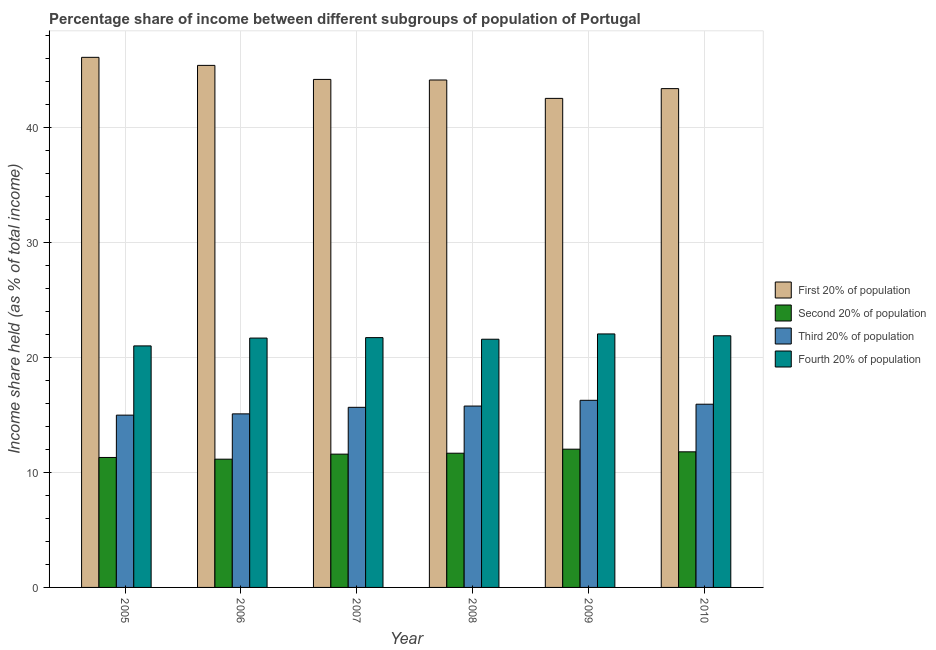How many different coloured bars are there?
Ensure brevity in your answer.  4. Are the number of bars per tick equal to the number of legend labels?
Make the answer very short. Yes. How many bars are there on the 2nd tick from the left?
Provide a succinct answer. 4. What is the label of the 5th group of bars from the left?
Your answer should be compact. 2009. What is the share of the income held by first 20% of the population in 2010?
Provide a succinct answer. 43.37. Across all years, what is the maximum share of the income held by second 20% of the population?
Make the answer very short. 12.02. Across all years, what is the minimum share of the income held by first 20% of the population?
Offer a very short reply. 42.52. In which year was the share of the income held by second 20% of the population maximum?
Offer a terse response. 2009. In which year was the share of the income held by third 20% of the population minimum?
Keep it short and to the point. 2005. What is the total share of the income held by first 20% of the population in the graph?
Provide a succinct answer. 265.66. What is the difference between the share of the income held by third 20% of the population in 2006 and that in 2008?
Offer a very short reply. -0.68. What is the difference between the share of the income held by second 20% of the population in 2007 and the share of the income held by fourth 20% of the population in 2006?
Offer a terse response. 0.44. What is the average share of the income held by third 20% of the population per year?
Offer a terse response. 15.62. In how many years, is the share of the income held by third 20% of the population greater than 2 %?
Ensure brevity in your answer.  6. What is the ratio of the share of the income held by first 20% of the population in 2005 to that in 2007?
Your answer should be compact. 1.04. Is the share of the income held by fourth 20% of the population in 2008 less than that in 2009?
Give a very brief answer. Yes. Is the difference between the share of the income held by third 20% of the population in 2005 and 2007 greater than the difference between the share of the income held by first 20% of the population in 2005 and 2007?
Make the answer very short. No. What is the difference between the highest and the second highest share of the income held by third 20% of the population?
Your response must be concise. 0.34. What is the difference between the highest and the lowest share of the income held by fourth 20% of the population?
Keep it short and to the point. 1.04. Is the sum of the share of the income held by first 20% of the population in 2008 and 2009 greater than the maximum share of the income held by fourth 20% of the population across all years?
Keep it short and to the point. Yes. Is it the case that in every year, the sum of the share of the income held by third 20% of the population and share of the income held by fourth 20% of the population is greater than the sum of share of the income held by second 20% of the population and share of the income held by first 20% of the population?
Provide a succinct answer. No. What does the 4th bar from the left in 2005 represents?
Offer a terse response. Fourth 20% of population. What does the 4th bar from the right in 2006 represents?
Your answer should be compact. First 20% of population. How many years are there in the graph?
Your response must be concise. 6. Does the graph contain grids?
Ensure brevity in your answer.  Yes. How many legend labels are there?
Offer a very short reply. 4. How are the legend labels stacked?
Keep it short and to the point. Vertical. What is the title of the graph?
Give a very brief answer. Percentage share of income between different subgroups of population of Portugal. What is the label or title of the Y-axis?
Give a very brief answer. Income share held (as % of total income). What is the Income share held (as % of total income) of First 20% of population in 2005?
Your response must be concise. 46.09. What is the Income share held (as % of total income) of Second 20% of population in 2005?
Your response must be concise. 11.3. What is the Income share held (as % of total income) in Third 20% of population in 2005?
Provide a succinct answer. 14.98. What is the Income share held (as % of total income) in First 20% of population in 2006?
Ensure brevity in your answer.  45.39. What is the Income share held (as % of total income) of Second 20% of population in 2006?
Give a very brief answer. 11.15. What is the Income share held (as % of total income) in Third 20% of population in 2006?
Offer a very short reply. 15.09. What is the Income share held (as % of total income) in Fourth 20% of population in 2006?
Keep it short and to the point. 21.68. What is the Income share held (as % of total income) in First 20% of population in 2007?
Provide a short and direct response. 44.17. What is the Income share held (as % of total income) in Second 20% of population in 2007?
Provide a succinct answer. 11.59. What is the Income share held (as % of total income) of Third 20% of population in 2007?
Provide a short and direct response. 15.66. What is the Income share held (as % of total income) of Fourth 20% of population in 2007?
Your answer should be very brief. 21.72. What is the Income share held (as % of total income) of First 20% of population in 2008?
Make the answer very short. 44.12. What is the Income share held (as % of total income) in Second 20% of population in 2008?
Your response must be concise. 11.67. What is the Income share held (as % of total income) in Third 20% of population in 2008?
Your response must be concise. 15.77. What is the Income share held (as % of total income) in Fourth 20% of population in 2008?
Ensure brevity in your answer.  21.58. What is the Income share held (as % of total income) of First 20% of population in 2009?
Your response must be concise. 42.52. What is the Income share held (as % of total income) of Second 20% of population in 2009?
Provide a succinct answer. 12.02. What is the Income share held (as % of total income) of Third 20% of population in 2009?
Offer a terse response. 16.27. What is the Income share held (as % of total income) of Fourth 20% of population in 2009?
Your answer should be very brief. 22.04. What is the Income share held (as % of total income) in First 20% of population in 2010?
Offer a very short reply. 43.37. What is the Income share held (as % of total income) of Second 20% of population in 2010?
Your answer should be very brief. 11.79. What is the Income share held (as % of total income) of Third 20% of population in 2010?
Offer a terse response. 15.93. What is the Income share held (as % of total income) of Fourth 20% of population in 2010?
Provide a short and direct response. 21.88. Across all years, what is the maximum Income share held (as % of total income) of First 20% of population?
Provide a succinct answer. 46.09. Across all years, what is the maximum Income share held (as % of total income) in Second 20% of population?
Give a very brief answer. 12.02. Across all years, what is the maximum Income share held (as % of total income) in Third 20% of population?
Your answer should be very brief. 16.27. Across all years, what is the maximum Income share held (as % of total income) in Fourth 20% of population?
Your response must be concise. 22.04. Across all years, what is the minimum Income share held (as % of total income) of First 20% of population?
Keep it short and to the point. 42.52. Across all years, what is the minimum Income share held (as % of total income) in Second 20% of population?
Provide a succinct answer. 11.15. Across all years, what is the minimum Income share held (as % of total income) in Third 20% of population?
Ensure brevity in your answer.  14.98. What is the total Income share held (as % of total income) in First 20% of population in the graph?
Offer a terse response. 265.66. What is the total Income share held (as % of total income) of Second 20% of population in the graph?
Ensure brevity in your answer.  69.52. What is the total Income share held (as % of total income) in Third 20% of population in the graph?
Your answer should be compact. 93.7. What is the total Income share held (as % of total income) in Fourth 20% of population in the graph?
Provide a succinct answer. 129.9. What is the difference between the Income share held (as % of total income) in Third 20% of population in 2005 and that in 2006?
Your response must be concise. -0.11. What is the difference between the Income share held (as % of total income) of Fourth 20% of population in 2005 and that in 2006?
Provide a succinct answer. -0.68. What is the difference between the Income share held (as % of total income) in First 20% of population in 2005 and that in 2007?
Offer a very short reply. 1.92. What is the difference between the Income share held (as % of total income) of Second 20% of population in 2005 and that in 2007?
Make the answer very short. -0.29. What is the difference between the Income share held (as % of total income) of Third 20% of population in 2005 and that in 2007?
Your response must be concise. -0.68. What is the difference between the Income share held (as % of total income) of Fourth 20% of population in 2005 and that in 2007?
Offer a terse response. -0.72. What is the difference between the Income share held (as % of total income) of First 20% of population in 2005 and that in 2008?
Your response must be concise. 1.97. What is the difference between the Income share held (as % of total income) of Second 20% of population in 2005 and that in 2008?
Offer a very short reply. -0.37. What is the difference between the Income share held (as % of total income) of Third 20% of population in 2005 and that in 2008?
Provide a short and direct response. -0.79. What is the difference between the Income share held (as % of total income) in Fourth 20% of population in 2005 and that in 2008?
Your answer should be compact. -0.58. What is the difference between the Income share held (as % of total income) of First 20% of population in 2005 and that in 2009?
Your answer should be compact. 3.57. What is the difference between the Income share held (as % of total income) of Second 20% of population in 2005 and that in 2009?
Your answer should be very brief. -0.72. What is the difference between the Income share held (as % of total income) of Third 20% of population in 2005 and that in 2009?
Your response must be concise. -1.29. What is the difference between the Income share held (as % of total income) in Fourth 20% of population in 2005 and that in 2009?
Provide a short and direct response. -1.04. What is the difference between the Income share held (as % of total income) of First 20% of population in 2005 and that in 2010?
Your answer should be compact. 2.72. What is the difference between the Income share held (as % of total income) of Second 20% of population in 2005 and that in 2010?
Offer a very short reply. -0.49. What is the difference between the Income share held (as % of total income) in Third 20% of population in 2005 and that in 2010?
Provide a short and direct response. -0.95. What is the difference between the Income share held (as % of total income) of Fourth 20% of population in 2005 and that in 2010?
Provide a short and direct response. -0.88. What is the difference between the Income share held (as % of total income) of First 20% of population in 2006 and that in 2007?
Provide a short and direct response. 1.22. What is the difference between the Income share held (as % of total income) of Second 20% of population in 2006 and that in 2007?
Your answer should be compact. -0.44. What is the difference between the Income share held (as % of total income) of Third 20% of population in 2006 and that in 2007?
Offer a very short reply. -0.57. What is the difference between the Income share held (as % of total income) in Fourth 20% of population in 2006 and that in 2007?
Make the answer very short. -0.04. What is the difference between the Income share held (as % of total income) of First 20% of population in 2006 and that in 2008?
Offer a very short reply. 1.27. What is the difference between the Income share held (as % of total income) in Second 20% of population in 2006 and that in 2008?
Offer a very short reply. -0.52. What is the difference between the Income share held (as % of total income) in Third 20% of population in 2006 and that in 2008?
Your answer should be very brief. -0.68. What is the difference between the Income share held (as % of total income) of Fourth 20% of population in 2006 and that in 2008?
Make the answer very short. 0.1. What is the difference between the Income share held (as % of total income) of First 20% of population in 2006 and that in 2009?
Offer a terse response. 2.87. What is the difference between the Income share held (as % of total income) in Second 20% of population in 2006 and that in 2009?
Give a very brief answer. -0.87. What is the difference between the Income share held (as % of total income) in Third 20% of population in 2006 and that in 2009?
Your response must be concise. -1.18. What is the difference between the Income share held (as % of total income) in Fourth 20% of population in 2006 and that in 2009?
Your response must be concise. -0.36. What is the difference between the Income share held (as % of total income) of First 20% of population in 2006 and that in 2010?
Offer a terse response. 2.02. What is the difference between the Income share held (as % of total income) in Second 20% of population in 2006 and that in 2010?
Give a very brief answer. -0.64. What is the difference between the Income share held (as % of total income) of Third 20% of population in 2006 and that in 2010?
Offer a terse response. -0.84. What is the difference between the Income share held (as % of total income) of Fourth 20% of population in 2006 and that in 2010?
Offer a very short reply. -0.2. What is the difference between the Income share held (as % of total income) of Second 20% of population in 2007 and that in 2008?
Make the answer very short. -0.08. What is the difference between the Income share held (as % of total income) in Third 20% of population in 2007 and that in 2008?
Ensure brevity in your answer.  -0.11. What is the difference between the Income share held (as % of total income) in Fourth 20% of population in 2007 and that in 2008?
Offer a terse response. 0.14. What is the difference between the Income share held (as % of total income) of First 20% of population in 2007 and that in 2009?
Provide a short and direct response. 1.65. What is the difference between the Income share held (as % of total income) of Second 20% of population in 2007 and that in 2009?
Your answer should be compact. -0.43. What is the difference between the Income share held (as % of total income) in Third 20% of population in 2007 and that in 2009?
Your answer should be very brief. -0.61. What is the difference between the Income share held (as % of total income) of Fourth 20% of population in 2007 and that in 2009?
Your answer should be compact. -0.32. What is the difference between the Income share held (as % of total income) in Third 20% of population in 2007 and that in 2010?
Offer a terse response. -0.27. What is the difference between the Income share held (as % of total income) in Fourth 20% of population in 2007 and that in 2010?
Your response must be concise. -0.16. What is the difference between the Income share held (as % of total income) in Second 20% of population in 2008 and that in 2009?
Offer a terse response. -0.35. What is the difference between the Income share held (as % of total income) of Fourth 20% of population in 2008 and that in 2009?
Keep it short and to the point. -0.46. What is the difference between the Income share held (as % of total income) in First 20% of population in 2008 and that in 2010?
Offer a terse response. 0.75. What is the difference between the Income share held (as % of total income) in Second 20% of population in 2008 and that in 2010?
Give a very brief answer. -0.12. What is the difference between the Income share held (as % of total income) in Third 20% of population in 2008 and that in 2010?
Make the answer very short. -0.16. What is the difference between the Income share held (as % of total income) of First 20% of population in 2009 and that in 2010?
Provide a succinct answer. -0.85. What is the difference between the Income share held (as % of total income) of Second 20% of population in 2009 and that in 2010?
Your answer should be compact. 0.23. What is the difference between the Income share held (as % of total income) in Third 20% of population in 2009 and that in 2010?
Your answer should be very brief. 0.34. What is the difference between the Income share held (as % of total income) of Fourth 20% of population in 2009 and that in 2010?
Ensure brevity in your answer.  0.16. What is the difference between the Income share held (as % of total income) of First 20% of population in 2005 and the Income share held (as % of total income) of Second 20% of population in 2006?
Provide a succinct answer. 34.94. What is the difference between the Income share held (as % of total income) in First 20% of population in 2005 and the Income share held (as % of total income) in Fourth 20% of population in 2006?
Offer a terse response. 24.41. What is the difference between the Income share held (as % of total income) in Second 20% of population in 2005 and the Income share held (as % of total income) in Third 20% of population in 2006?
Offer a terse response. -3.79. What is the difference between the Income share held (as % of total income) in Second 20% of population in 2005 and the Income share held (as % of total income) in Fourth 20% of population in 2006?
Ensure brevity in your answer.  -10.38. What is the difference between the Income share held (as % of total income) in First 20% of population in 2005 and the Income share held (as % of total income) in Second 20% of population in 2007?
Offer a very short reply. 34.5. What is the difference between the Income share held (as % of total income) of First 20% of population in 2005 and the Income share held (as % of total income) of Third 20% of population in 2007?
Provide a succinct answer. 30.43. What is the difference between the Income share held (as % of total income) in First 20% of population in 2005 and the Income share held (as % of total income) in Fourth 20% of population in 2007?
Your answer should be compact. 24.37. What is the difference between the Income share held (as % of total income) of Second 20% of population in 2005 and the Income share held (as % of total income) of Third 20% of population in 2007?
Your response must be concise. -4.36. What is the difference between the Income share held (as % of total income) of Second 20% of population in 2005 and the Income share held (as % of total income) of Fourth 20% of population in 2007?
Provide a succinct answer. -10.42. What is the difference between the Income share held (as % of total income) in Third 20% of population in 2005 and the Income share held (as % of total income) in Fourth 20% of population in 2007?
Your response must be concise. -6.74. What is the difference between the Income share held (as % of total income) of First 20% of population in 2005 and the Income share held (as % of total income) of Second 20% of population in 2008?
Your answer should be compact. 34.42. What is the difference between the Income share held (as % of total income) of First 20% of population in 2005 and the Income share held (as % of total income) of Third 20% of population in 2008?
Make the answer very short. 30.32. What is the difference between the Income share held (as % of total income) in First 20% of population in 2005 and the Income share held (as % of total income) in Fourth 20% of population in 2008?
Keep it short and to the point. 24.51. What is the difference between the Income share held (as % of total income) in Second 20% of population in 2005 and the Income share held (as % of total income) in Third 20% of population in 2008?
Your response must be concise. -4.47. What is the difference between the Income share held (as % of total income) of Second 20% of population in 2005 and the Income share held (as % of total income) of Fourth 20% of population in 2008?
Your answer should be compact. -10.28. What is the difference between the Income share held (as % of total income) of Third 20% of population in 2005 and the Income share held (as % of total income) of Fourth 20% of population in 2008?
Provide a succinct answer. -6.6. What is the difference between the Income share held (as % of total income) in First 20% of population in 2005 and the Income share held (as % of total income) in Second 20% of population in 2009?
Ensure brevity in your answer.  34.07. What is the difference between the Income share held (as % of total income) of First 20% of population in 2005 and the Income share held (as % of total income) of Third 20% of population in 2009?
Your answer should be very brief. 29.82. What is the difference between the Income share held (as % of total income) in First 20% of population in 2005 and the Income share held (as % of total income) in Fourth 20% of population in 2009?
Your answer should be very brief. 24.05. What is the difference between the Income share held (as % of total income) of Second 20% of population in 2005 and the Income share held (as % of total income) of Third 20% of population in 2009?
Your response must be concise. -4.97. What is the difference between the Income share held (as % of total income) in Second 20% of population in 2005 and the Income share held (as % of total income) in Fourth 20% of population in 2009?
Make the answer very short. -10.74. What is the difference between the Income share held (as % of total income) of Third 20% of population in 2005 and the Income share held (as % of total income) of Fourth 20% of population in 2009?
Provide a succinct answer. -7.06. What is the difference between the Income share held (as % of total income) of First 20% of population in 2005 and the Income share held (as % of total income) of Second 20% of population in 2010?
Provide a short and direct response. 34.3. What is the difference between the Income share held (as % of total income) of First 20% of population in 2005 and the Income share held (as % of total income) of Third 20% of population in 2010?
Keep it short and to the point. 30.16. What is the difference between the Income share held (as % of total income) in First 20% of population in 2005 and the Income share held (as % of total income) in Fourth 20% of population in 2010?
Your answer should be compact. 24.21. What is the difference between the Income share held (as % of total income) in Second 20% of population in 2005 and the Income share held (as % of total income) in Third 20% of population in 2010?
Your answer should be compact. -4.63. What is the difference between the Income share held (as % of total income) of Second 20% of population in 2005 and the Income share held (as % of total income) of Fourth 20% of population in 2010?
Keep it short and to the point. -10.58. What is the difference between the Income share held (as % of total income) in First 20% of population in 2006 and the Income share held (as % of total income) in Second 20% of population in 2007?
Your response must be concise. 33.8. What is the difference between the Income share held (as % of total income) of First 20% of population in 2006 and the Income share held (as % of total income) of Third 20% of population in 2007?
Make the answer very short. 29.73. What is the difference between the Income share held (as % of total income) of First 20% of population in 2006 and the Income share held (as % of total income) of Fourth 20% of population in 2007?
Provide a short and direct response. 23.67. What is the difference between the Income share held (as % of total income) of Second 20% of population in 2006 and the Income share held (as % of total income) of Third 20% of population in 2007?
Offer a very short reply. -4.51. What is the difference between the Income share held (as % of total income) in Second 20% of population in 2006 and the Income share held (as % of total income) in Fourth 20% of population in 2007?
Ensure brevity in your answer.  -10.57. What is the difference between the Income share held (as % of total income) of Third 20% of population in 2006 and the Income share held (as % of total income) of Fourth 20% of population in 2007?
Give a very brief answer. -6.63. What is the difference between the Income share held (as % of total income) of First 20% of population in 2006 and the Income share held (as % of total income) of Second 20% of population in 2008?
Offer a terse response. 33.72. What is the difference between the Income share held (as % of total income) of First 20% of population in 2006 and the Income share held (as % of total income) of Third 20% of population in 2008?
Make the answer very short. 29.62. What is the difference between the Income share held (as % of total income) in First 20% of population in 2006 and the Income share held (as % of total income) in Fourth 20% of population in 2008?
Provide a short and direct response. 23.81. What is the difference between the Income share held (as % of total income) in Second 20% of population in 2006 and the Income share held (as % of total income) in Third 20% of population in 2008?
Offer a terse response. -4.62. What is the difference between the Income share held (as % of total income) in Second 20% of population in 2006 and the Income share held (as % of total income) in Fourth 20% of population in 2008?
Provide a succinct answer. -10.43. What is the difference between the Income share held (as % of total income) of Third 20% of population in 2006 and the Income share held (as % of total income) of Fourth 20% of population in 2008?
Keep it short and to the point. -6.49. What is the difference between the Income share held (as % of total income) of First 20% of population in 2006 and the Income share held (as % of total income) of Second 20% of population in 2009?
Offer a terse response. 33.37. What is the difference between the Income share held (as % of total income) of First 20% of population in 2006 and the Income share held (as % of total income) of Third 20% of population in 2009?
Ensure brevity in your answer.  29.12. What is the difference between the Income share held (as % of total income) in First 20% of population in 2006 and the Income share held (as % of total income) in Fourth 20% of population in 2009?
Ensure brevity in your answer.  23.35. What is the difference between the Income share held (as % of total income) in Second 20% of population in 2006 and the Income share held (as % of total income) in Third 20% of population in 2009?
Offer a very short reply. -5.12. What is the difference between the Income share held (as % of total income) of Second 20% of population in 2006 and the Income share held (as % of total income) of Fourth 20% of population in 2009?
Give a very brief answer. -10.89. What is the difference between the Income share held (as % of total income) in Third 20% of population in 2006 and the Income share held (as % of total income) in Fourth 20% of population in 2009?
Ensure brevity in your answer.  -6.95. What is the difference between the Income share held (as % of total income) of First 20% of population in 2006 and the Income share held (as % of total income) of Second 20% of population in 2010?
Keep it short and to the point. 33.6. What is the difference between the Income share held (as % of total income) of First 20% of population in 2006 and the Income share held (as % of total income) of Third 20% of population in 2010?
Your response must be concise. 29.46. What is the difference between the Income share held (as % of total income) in First 20% of population in 2006 and the Income share held (as % of total income) in Fourth 20% of population in 2010?
Offer a terse response. 23.51. What is the difference between the Income share held (as % of total income) in Second 20% of population in 2006 and the Income share held (as % of total income) in Third 20% of population in 2010?
Your answer should be compact. -4.78. What is the difference between the Income share held (as % of total income) in Second 20% of population in 2006 and the Income share held (as % of total income) in Fourth 20% of population in 2010?
Your answer should be compact. -10.73. What is the difference between the Income share held (as % of total income) of Third 20% of population in 2006 and the Income share held (as % of total income) of Fourth 20% of population in 2010?
Provide a short and direct response. -6.79. What is the difference between the Income share held (as % of total income) in First 20% of population in 2007 and the Income share held (as % of total income) in Second 20% of population in 2008?
Make the answer very short. 32.5. What is the difference between the Income share held (as % of total income) in First 20% of population in 2007 and the Income share held (as % of total income) in Third 20% of population in 2008?
Your response must be concise. 28.4. What is the difference between the Income share held (as % of total income) of First 20% of population in 2007 and the Income share held (as % of total income) of Fourth 20% of population in 2008?
Keep it short and to the point. 22.59. What is the difference between the Income share held (as % of total income) in Second 20% of population in 2007 and the Income share held (as % of total income) in Third 20% of population in 2008?
Your response must be concise. -4.18. What is the difference between the Income share held (as % of total income) of Second 20% of population in 2007 and the Income share held (as % of total income) of Fourth 20% of population in 2008?
Keep it short and to the point. -9.99. What is the difference between the Income share held (as % of total income) in Third 20% of population in 2007 and the Income share held (as % of total income) in Fourth 20% of population in 2008?
Give a very brief answer. -5.92. What is the difference between the Income share held (as % of total income) in First 20% of population in 2007 and the Income share held (as % of total income) in Second 20% of population in 2009?
Make the answer very short. 32.15. What is the difference between the Income share held (as % of total income) of First 20% of population in 2007 and the Income share held (as % of total income) of Third 20% of population in 2009?
Give a very brief answer. 27.9. What is the difference between the Income share held (as % of total income) of First 20% of population in 2007 and the Income share held (as % of total income) of Fourth 20% of population in 2009?
Your answer should be very brief. 22.13. What is the difference between the Income share held (as % of total income) in Second 20% of population in 2007 and the Income share held (as % of total income) in Third 20% of population in 2009?
Your response must be concise. -4.68. What is the difference between the Income share held (as % of total income) in Second 20% of population in 2007 and the Income share held (as % of total income) in Fourth 20% of population in 2009?
Your response must be concise. -10.45. What is the difference between the Income share held (as % of total income) of Third 20% of population in 2007 and the Income share held (as % of total income) of Fourth 20% of population in 2009?
Provide a succinct answer. -6.38. What is the difference between the Income share held (as % of total income) in First 20% of population in 2007 and the Income share held (as % of total income) in Second 20% of population in 2010?
Your answer should be compact. 32.38. What is the difference between the Income share held (as % of total income) in First 20% of population in 2007 and the Income share held (as % of total income) in Third 20% of population in 2010?
Offer a terse response. 28.24. What is the difference between the Income share held (as % of total income) of First 20% of population in 2007 and the Income share held (as % of total income) of Fourth 20% of population in 2010?
Your response must be concise. 22.29. What is the difference between the Income share held (as % of total income) in Second 20% of population in 2007 and the Income share held (as % of total income) in Third 20% of population in 2010?
Offer a very short reply. -4.34. What is the difference between the Income share held (as % of total income) of Second 20% of population in 2007 and the Income share held (as % of total income) of Fourth 20% of population in 2010?
Your answer should be compact. -10.29. What is the difference between the Income share held (as % of total income) of Third 20% of population in 2007 and the Income share held (as % of total income) of Fourth 20% of population in 2010?
Offer a terse response. -6.22. What is the difference between the Income share held (as % of total income) of First 20% of population in 2008 and the Income share held (as % of total income) of Second 20% of population in 2009?
Provide a short and direct response. 32.1. What is the difference between the Income share held (as % of total income) of First 20% of population in 2008 and the Income share held (as % of total income) of Third 20% of population in 2009?
Offer a very short reply. 27.85. What is the difference between the Income share held (as % of total income) of First 20% of population in 2008 and the Income share held (as % of total income) of Fourth 20% of population in 2009?
Give a very brief answer. 22.08. What is the difference between the Income share held (as % of total income) in Second 20% of population in 2008 and the Income share held (as % of total income) in Fourth 20% of population in 2009?
Provide a succinct answer. -10.37. What is the difference between the Income share held (as % of total income) of Third 20% of population in 2008 and the Income share held (as % of total income) of Fourth 20% of population in 2009?
Provide a short and direct response. -6.27. What is the difference between the Income share held (as % of total income) in First 20% of population in 2008 and the Income share held (as % of total income) in Second 20% of population in 2010?
Offer a terse response. 32.33. What is the difference between the Income share held (as % of total income) of First 20% of population in 2008 and the Income share held (as % of total income) of Third 20% of population in 2010?
Ensure brevity in your answer.  28.19. What is the difference between the Income share held (as % of total income) in First 20% of population in 2008 and the Income share held (as % of total income) in Fourth 20% of population in 2010?
Your response must be concise. 22.24. What is the difference between the Income share held (as % of total income) in Second 20% of population in 2008 and the Income share held (as % of total income) in Third 20% of population in 2010?
Your answer should be compact. -4.26. What is the difference between the Income share held (as % of total income) in Second 20% of population in 2008 and the Income share held (as % of total income) in Fourth 20% of population in 2010?
Provide a succinct answer. -10.21. What is the difference between the Income share held (as % of total income) of Third 20% of population in 2008 and the Income share held (as % of total income) of Fourth 20% of population in 2010?
Ensure brevity in your answer.  -6.11. What is the difference between the Income share held (as % of total income) of First 20% of population in 2009 and the Income share held (as % of total income) of Second 20% of population in 2010?
Offer a terse response. 30.73. What is the difference between the Income share held (as % of total income) of First 20% of population in 2009 and the Income share held (as % of total income) of Third 20% of population in 2010?
Your answer should be compact. 26.59. What is the difference between the Income share held (as % of total income) of First 20% of population in 2009 and the Income share held (as % of total income) of Fourth 20% of population in 2010?
Your answer should be very brief. 20.64. What is the difference between the Income share held (as % of total income) of Second 20% of population in 2009 and the Income share held (as % of total income) of Third 20% of population in 2010?
Give a very brief answer. -3.91. What is the difference between the Income share held (as % of total income) of Second 20% of population in 2009 and the Income share held (as % of total income) of Fourth 20% of population in 2010?
Offer a very short reply. -9.86. What is the difference between the Income share held (as % of total income) in Third 20% of population in 2009 and the Income share held (as % of total income) in Fourth 20% of population in 2010?
Your answer should be very brief. -5.61. What is the average Income share held (as % of total income) in First 20% of population per year?
Provide a short and direct response. 44.28. What is the average Income share held (as % of total income) in Second 20% of population per year?
Your answer should be very brief. 11.59. What is the average Income share held (as % of total income) in Third 20% of population per year?
Make the answer very short. 15.62. What is the average Income share held (as % of total income) in Fourth 20% of population per year?
Offer a very short reply. 21.65. In the year 2005, what is the difference between the Income share held (as % of total income) of First 20% of population and Income share held (as % of total income) of Second 20% of population?
Ensure brevity in your answer.  34.79. In the year 2005, what is the difference between the Income share held (as % of total income) in First 20% of population and Income share held (as % of total income) in Third 20% of population?
Provide a short and direct response. 31.11. In the year 2005, what is the difference between the Income share held (as % of total income) of First 20% of population and Income share held (as % of total income) of Fourth 20% of population?
Make the answer very short. 25.09. In the year 2005, what is the difference between the Income share held (as % of total income) of Second 20% of population and Income share held (as % of total income) of Third 20% of population?
Provide a short and direct response. -3.68. In the year 2005, what is the difference between the Income share held (as % of total income) of Second 20% of population and Income share held (as % of total income) of Fourth 20% of population?
Offer a very short reply. -9.7. In the year 2005, what is the difference between the Income share held (as % of total income) in Third 20% of population and Income share held (as % of total income) in Fourth 20% of population?
Provide a short and direct response. -6.02. In the year 2006, what is the difference between the Income share held (as % of total income) in First 20% of population and Income share held (as % of total income) in Second 20% of population?
Give a very brief answer. 34.24. In the year 2006, what is the difference between the Income share held (as % of total income) in First 20% of population and Income share held (as % of total income) in Third 20% of population?
Offer a very short reply. 30.3. In the year 2006, what is the difference between the Income share held (as % of total income) in First 20% of population and Income share held (as % of total income) in Fourth 20% of population?
Your answer should be very brief. 23.71. In the year 2006, what is the difference between the Income share held (as % of total income) in Second 20% of population and Income share held (as % of total income) in Third 20% of population?
Keep it short and to the point. -3.94. In the year 2006, what is the difference between the Income share held (as % of total income) of Second 20% of population and Income share held (as % of total income) of Fourth 20% of population?
Offer a very short reply. -10.53. In the year 2006, what is the difference between the Income share held (as % of total income) of Third 20% of population and Income share held (as % of total income) of Fourth 20% of population?
Your answer should be very brief. -6.59. In the year 2007, what is the difference between the Income share held (as % of total income) of First 20% of population and Income share held (as % of total income) of Second 20% of population?
Offer a terse response. 32.58. In the year 2007, what is the difference between the Income share held (as % of total income) of First 20% of population and Income share held (as % of total income) of Third 20% of population?
Make the answer very short. 28.51. In the year 2007, what is the difference between the Income share held (as % of total income) of First 20% of population and Income share held (as % of total income) of Fourth 20% of population?
Provide a succinct answer. 22.45. In the year 2007, what is the difference between the Income share held (as % of total income) in Second 20% of population and Income share held (as % of total income) in Third 20% of population?
Provide a succinct answer. -4.07. In the year 2007, what is the difference between the Income share held (as % of total income) of Second 20% of population and Income share held (as % of total income) of Fourth 20% of population?
Ensure brevity in your answer.  -10.13. In the year 2007, what is the difference between the Income share held (as % of total income) in Third 20% of population and Income share held (as % of total income) in Fourth 20% of population?
Give a very brief answer. -6.06. In the year 2008, what is the difference between the Income share held (as % of total income) of First 20% of population and Income share held (as % of total income) of Second 20% of population?
Ensure brevity in your answer.  32.45. In the year 2008, what is the difference between the Income share held (as % of total income) of First 20% of population and Income share held (as % of total income) of Third 20% of population?
Offer a terse response. 28.35. In the year 2008, what is the difference between the Income share held (as % of total income) in First 20% of population and Income share held (as % of total income) in Fourth 20% of population?
Provide a short and direct response. 22.54. In the year 2008, what is the difference between the Income share held (as % of total income) in Second 20% of population and Income share held (as % of total income) in Third 20% of population?
Make the answer very short. -4.1. In the year 2008, what is the difference between the Income share held (as % of total income) in Second 20% of population and Income share held (as % of total income) in Fourth 20% of population?
Keep it short and to the point. -9.91. In the year 2008, what is the difference between the Income share held (as % of total income) of Third 20% of population and Income share held (as % of total income) of Fourth 20% of population?
Offer a very short reply. -5.81. In the year 2009, what is the difference between the Income share held (as % of total income) of First 20% of population and Income share held (as % of total income) of Second 20% of population?
Give a very brief answer. 30.5. In the year 2009, what is the difference between the Income share held (as % of total income) in First 20% of population and Income share held (as % of total income) in Third 20% of population?
Provide a short and direct response. 26.25. In the year 2009, what is the difference between the Income share held (as % of total income) of First 20% of population and Income share held (as % of total income) of Fourth 20% of population?
Make the answer very short. 20.48. In the year 2009, what is the difference between the Income share held (as % of total income) of Second 20% of population and Income share held (as % of total income) of Third 20% of population?
Offer a terse response. -4.25. In the year 2009, what is the difference between the Income share held (as % of total income) in Second 20% of population and Income share held (as % of total income) in Fourth 20% of population?
Offer a very short reply. -10.02. In the year 2009, what is the difference between the Income share held (as % of total income) in Third 20% of population and Income share held (as % of total income) in Fourth 20% of population?
Your answer should be very brief. -5.77. In the year 2010, what is the difference between the Income share held (as % of total income) of First 20% of population and Income share held (as % of total income) of Second 20% of population?
Make the answer very short. 31.58. In the year 2010, what is the difference between the Income share held (as % of total income) in First 20% of population and Income share held (as % of total income) in Third 20% of population?
Offer a terse response. 27.44. In the year 2010, what is the difference between the Income share held (as % of total income) of First 20% of population and Income share held (as % of total income) of Fourth 20% of population?
Offer a very short reply. 21.49. In the year 2010, what is the difference between the Income share held (as % of total income) of Second 20% of population and Income share held (as % of total income) of Third 20% of population?
Ensure brevity in your answer.  -4.14. In the year 2010, what is the difference between the Income share held (as % of total income) of Second 20% of population and Income share held (as % of total income) of Fourth 20% of population?
Offer a terse response. -10.09. In the year 2010, what is the difference between the Income share held (as % of total income) of Third 20% of population and Income share held (as % of total income) of Fourth 20% of population?
Offer a terse response. -5.95. What is the ratio of the Income share held (as % of total income) of First 20% of population in 2005 to that in 2006?
Give a very brief answer. 1.02. What is the ratio of the Income share held (as % of total income) of Second 20% of population in 2005 to that in 2006?
Keep it short and to the point. 1.01. What is the ratio of the Income share held (as % of total income) of Fourth 20% of population in 2005 to that in 2006?
Ensure brevity in your answer.  0.97. What is the ratio of the Income share held (as % of total income) in First 20% of population in 2005 to that in 2007?
Ensure brevity in your answer.  1.04. What is the ratio of the Income share held (as % of total income) of Second 20% of population in 2005 to that in 2007?
Your response must be concise. 0.97. What is the ratio of the Income share held (as % of total income) of Third 20% of population in 2005 to that in 2007?
Keep it short and to the point. 0.96. What is the ratio of the Income share held (as % of total income) of Fourth 20% of population in 2005 to that in 2007?
Keep it short and to the point. 0.97. What is the ratio of the Income share held (as % of total income) of First 20% of population in 2005 to that in 2008?
Your response must be concise. 1.04. What is the ratio of the Income share held (as % of total income) of Second 20% of population in 2005 to that in 2008?
Your answer should be very brief. 0.97. What is the ratio of the Income share held (as % of total income) in Third 20% of population in 2005 to that in 2008?
Offer a very short reply. 0.95. What is the ratio of the Income share held (as % of total income) in Fourth 20% of population in 2005 to that in 2008?
Give a very brief answer. 0.97. What is the ratio of the Income share held (as % of total income) in First 20% of population in 2005 to that in 2009?
Provide a short and direct response. 1.08. What is the ratio of the Income share held (as % of total income) of Second 20% of population in 2005 to that in 2009?
Your response must be concise. 0.94. What is the ratio of the Income share held (as % of total income) of Third 20% of population in 2005 to that in 2009?
Your response must be concise. 0.92. What is the ratio of the Income share held (as % of total income) of Fourth 20% of population in 2005 to that in 2009?
Offer a terse response. 0.95. What is the ratio of the Income share held (as % of total income) in First 20% of population in 2005 to that in 2010?
Provide a succinct answer. 1.06. What is the ratio of the Income share held (as % of total income) in Second 20% of population in 2005 to that in 2010?
Offer a terse response. 0.96. What is the ratio of the Income share held (as % of total income) of Third 20% of population in 2005 to that in 2010?
Make the answer very short. 0.94. What is the ratio of the Income share held (as % of total income) in Fourth 20% of population in 2005 to that in 2010?
Your response must be concise. 0.96. What is the ratio of the Income share held (as % of total income) of First 20% of population in 2006 to that in 2007?
Keep it short and to the point. 1.03. What is the ratio of the Income share held (as % of total income) in Second 20% of population in 2006 to that in 2007?
Offer a very short reply. 0.96. What is the ratio of the Income share held (as % of total income) in Third 20% of population in 2006 to that in 2007?
Give a very brief answer. 0.96. What is the ratio of the Income share held (as % of total income) of Fourth 20% of population in 2006 to that in 2007?
Make the answer very short. 1. What is the ratio of the Income share held (as % of total income) in First 20% of population in 2006 to that in 2008?
Offer a terse response. 1.03. What is the ratio of the Income share held (as % of total income) in Second 20% of population in 2006 to that in 2008?
Your response must be concise. 0.96. What is the ratio of the Income share held (as % of total income) in Third 20% of population in 2006 to that in 2008?
Make the answer very short. 0.96. What is the ratio of the Income share held (as % of total income) of First 20% of population in 2006 to that in 2009?
Ensure brevity in your answer.  1.07. What is the ratio of the Income share held (as % of total income) of Second 20% of population in 2006 to that in 2009?
Provide a short and direct response. 0.93. What is the ratio of the Income share held (as % of total income) of Third 20% of population in 2006 to that in 2009?
Keep it short and to the point. 0.93. What is the ratio of the Income share held (as % of total income) of Fourth 20% of population in 2006 to that in 2009?
Ensure brevity in your answer.  0.98. What is the ratio of the Income share held (as % of total income) in First 20% of population in 2006 to that in 2010?
Ensure brevity in your answer.  1.05. What is the ratio of the Income share held (as % of total income) of Second 20% of population in 2006 to that in 2010?
Make the answer very short. 0.95. What is the ratio of the Income share held (as % of total income) of Third 20% of population in 2006 to that in 2010?
Offer a terse response. 0.95. What is the ratio of the Income share held (as % of total income) of Fourth 20% of population in 2006 to that in 2010?
Keep it short and to the point. 0.99. What is the ratio of the Income share held (as % of total income) in First 20% of population in 2007 to that in 2008?
Your answer should be compact. 1. What is the ratio of the Income share held (as % of total income) in Third 20% of population in 2007 to that in 2008?
Your answer should be very brief. 0.99. What is the ratio of the Income share held (as % of total income) in First 20% of population in 2007 to that in 2009?
Your answer should be very brief. 1.04. What is the ratio of the Income share held (as % of total income) in Second 20% of population in 2007 to that in 2009?
Offer a terse response. 0.96. What is the ratio of the Income share held (as % of total income) of Third 20% of population in 2007 to that in 2009?
Your response must be concise. 0.96. What is the ratio of the Income share held (as % of total income) in Fourth 20% of population in 2007 to that in 2009?
Your response must be concise. 0.99. What is the ratio of the Income share held (as % of total income) in First 20% of population in 2007 to that in 2010?
Provide a short and direct response. 1.02. What is the ratio of the Income share held (as % of total income) in Second 20% of population in 2007 to that in 2010?
Give a very brief answer. 0.98. What is the ratio of the Income share held (as % of total income) in Third 20% of population in 2007 to that in 2010?
Keep it short and to the point. 0.98. What is the ratio of the Income share held (as % of total income) of First 20% of population in 2008 to that in 2009?
Your answer should be very brief. 1.04. What is the ratio of the Income share held (as % of total income) of Second 20% of population in 2008 to that in 2009?
Give a very brief answer. 0.97. What is the ratio of the Income share held (as % of total income) in Third 20% of population in 2008 to that in 2009?
Your answer should be very brief. 0.97. What is the ratio of the Income share held (as % of total income) in Fourth 20% of population in 2008 to that in 2009?
Your answer should be compact. 0.98. What is the ratio of the Income share held (as % of total income) in First 20% of population in 2008 to that in 2010?
Keep it short and to the point. 1.02. What is the ratio of the Income share held (as % of total income) in Second 20% of population in 2008 to that in 2010?
Your answer should be very brief. 0.99. What is the ratio of the Income share held (as % of total income) in Fourth 20% of population in 2008 to that in 2010?
Ensure brevity in your answer.  0.99. What is the ratio of the Income share held (as % of total income) in First 20% of population in 2009 to that in 2010?
Give a very brief answer. 0.98. What is the ratio of the Income share held (as % of total income) in Second 20% of population in 2009 to that in 2010?
Ensure brevity in your answer.  1.02. What is the ratio of the Income share held (as % of total income) of Third 20% of population in 2009 to that in 2010?
Provide a succinct answer. 1.02. What is the ratio of the Income share held (as % of total income) of Fourth 20% of population in 2009 to that in 2010?
Give a very brief answer. 1.01. What is the difference between the highest and the second highest Income share held (as % of total income) of First 20% of population?
Make the answer very short. 0.7. What is the difference between the highest and the second highest Income share held (as % of total income) in Second 20% of population?
Offer a terse response. 0.23. What is the difference between the highest and the second highest Income share held (as % of total income) in Third 20% of population?
Your response must be concise. 0.34. What is the difference between the highest and the second highest Income share held (as % of total income) of Fourth 20% of population?
Your answer should be compact. 0.16. What is the difference between the highest and the lowest Income share held (as % of total income) in First 20% of population?
Provide a short and direct response. 3.57. What is the difference between the highest and the lowest Income share held (as % of total income) of Second 20% of population?
Your answer should be very brief. 0.87. What is the difference between the highest and the lowest Income share held (as % of total income) in Third 20% of population?
Offer a terse response. 1.29. What is the difference between the highest and the lowest Income share held (as % of total income) in Fourth 20% of population?
Your response must be concise. 1.04. 